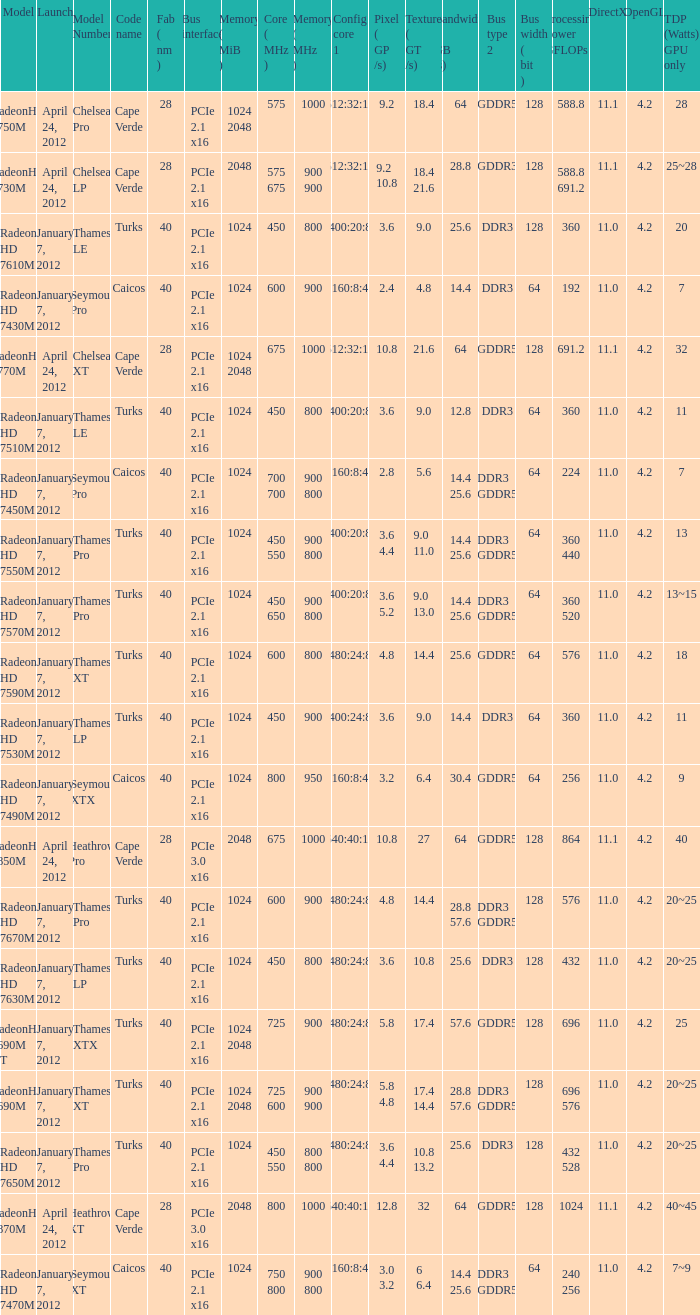What is the config core 1 of the model with a processing power GFLOPs of 432? 480:24:8. 